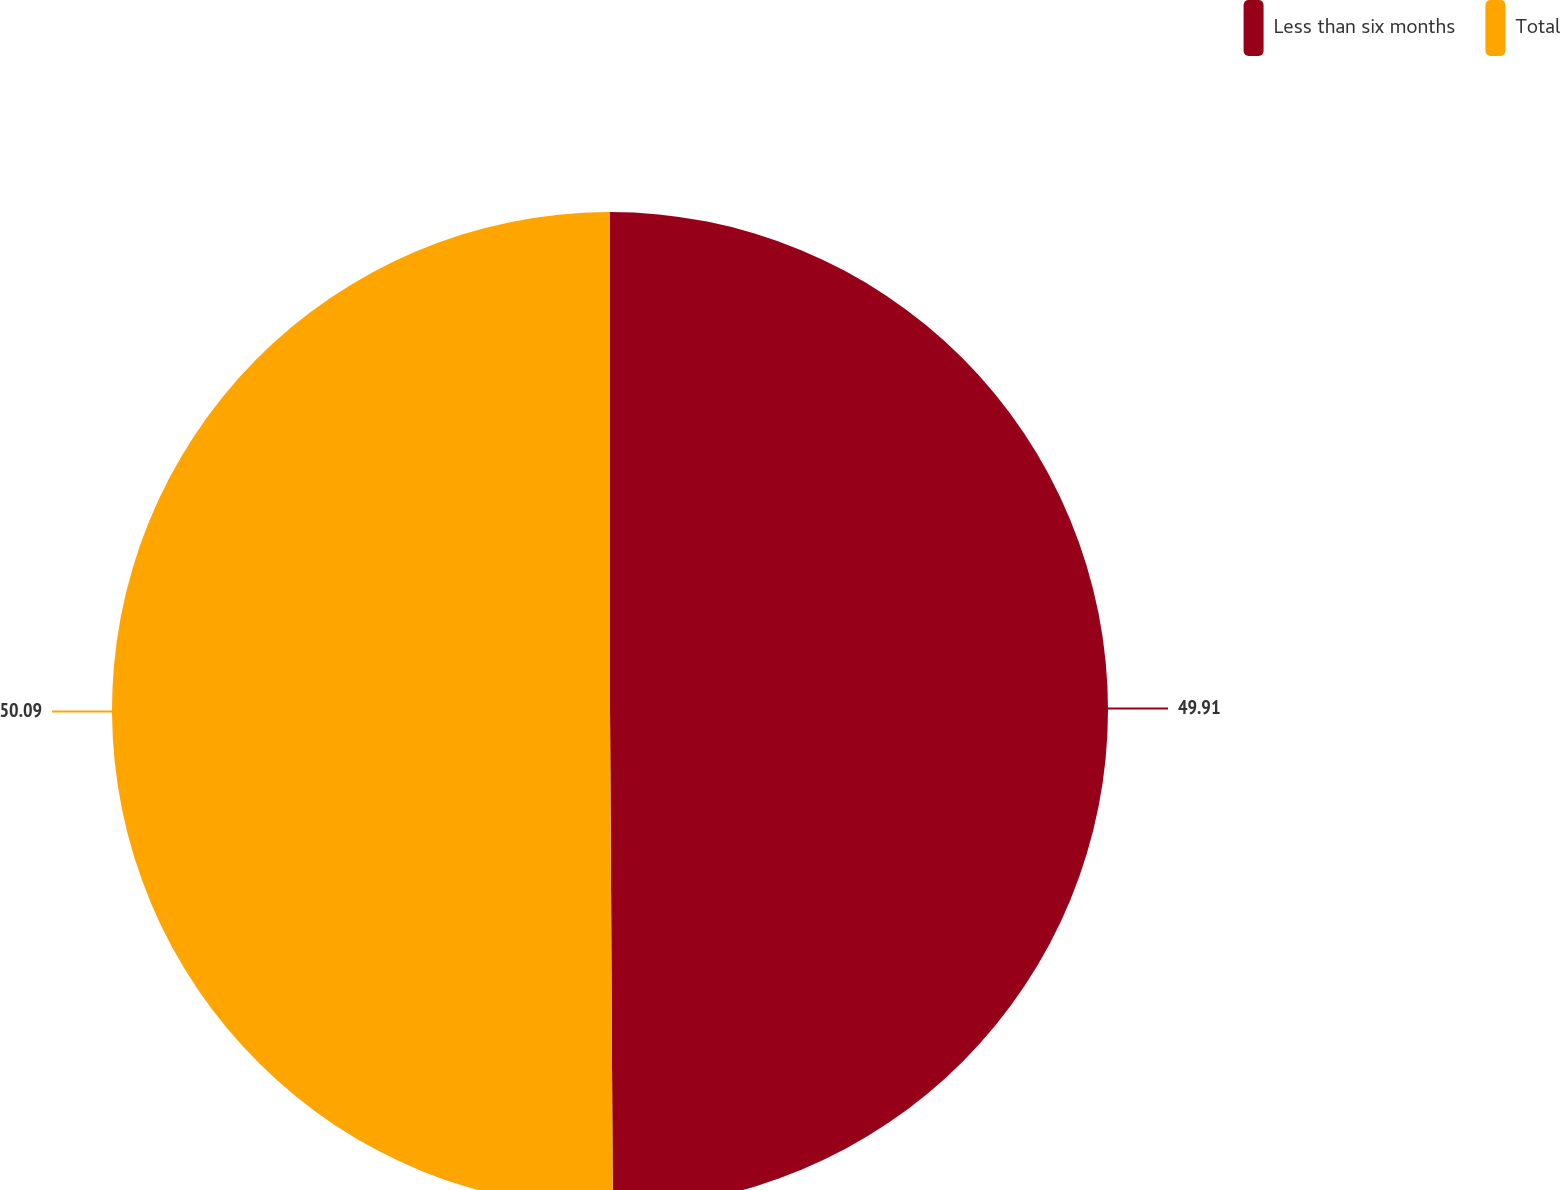<chart> <loc_0><loc_0><loc_500><loc_500><pie_chart><fcel>Less than six months<fcel>Total<nl><fcel>49.91%<fcel>50.09%<nl></chart> 